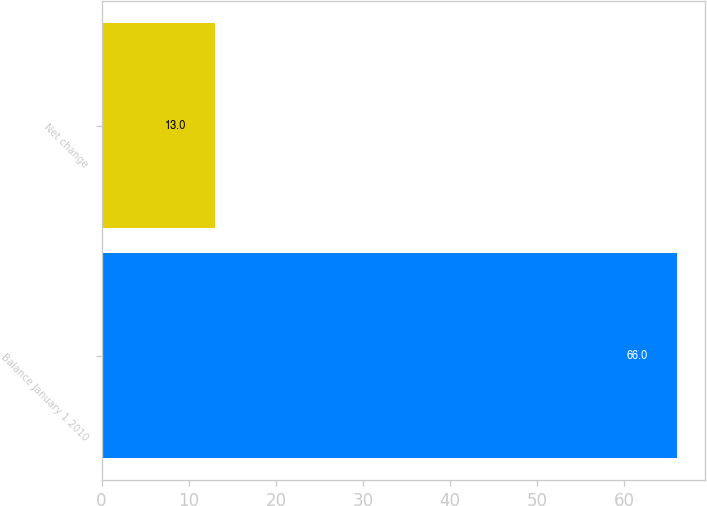<chart> <loc_0><loc_0><loc_500><loc_500><bar_chart><fcel>Balance January 1 2010<fcel>Net change<nl><fcel>66<fcel>13<nl></chart> 